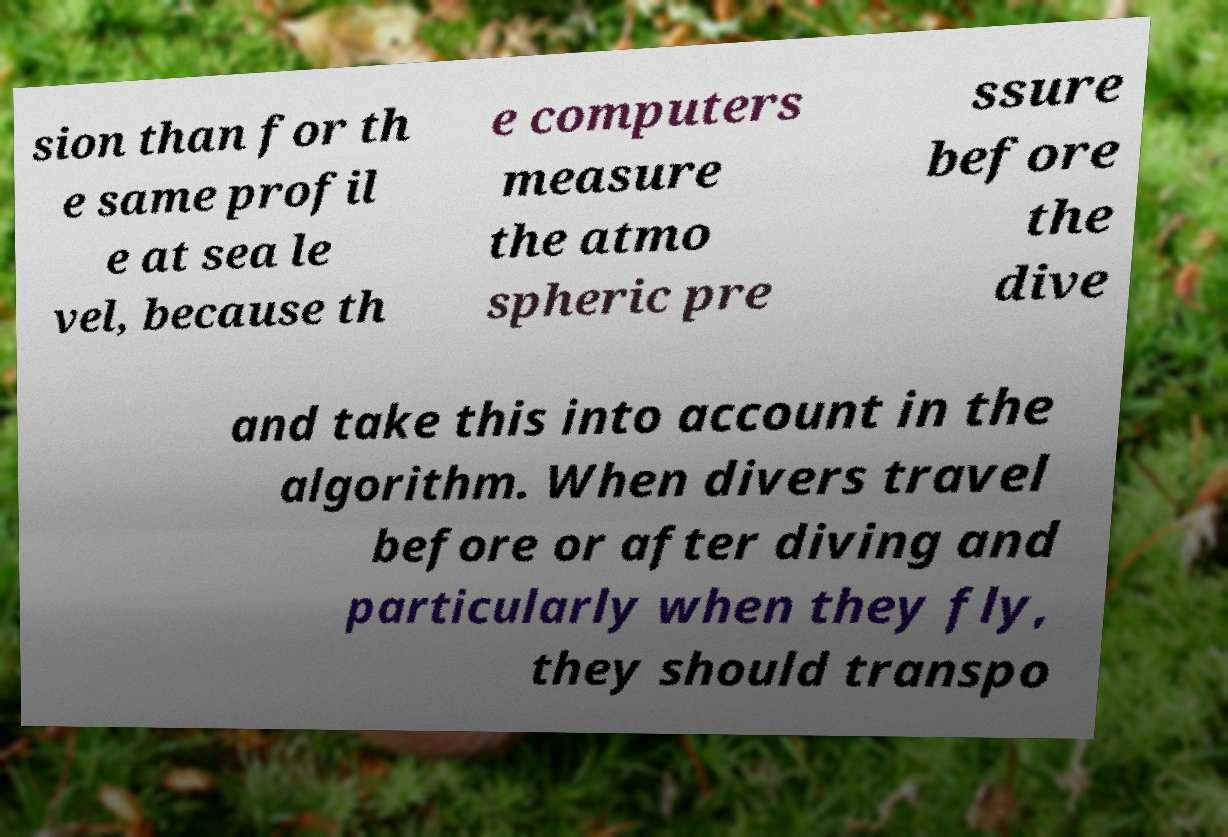Could you extract and type out the text from this image? sion than for th e same profil e at sea le vel, because th e computers measure the atmo spheric pre ssure before the dive and take this into account in the algorithm. When divers travel before or after diving and particularly when they fly, they should transpo 